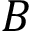Convert formula to latex. <formula><loc_0><loc_0><loc_500><loc_500>B</formula> 